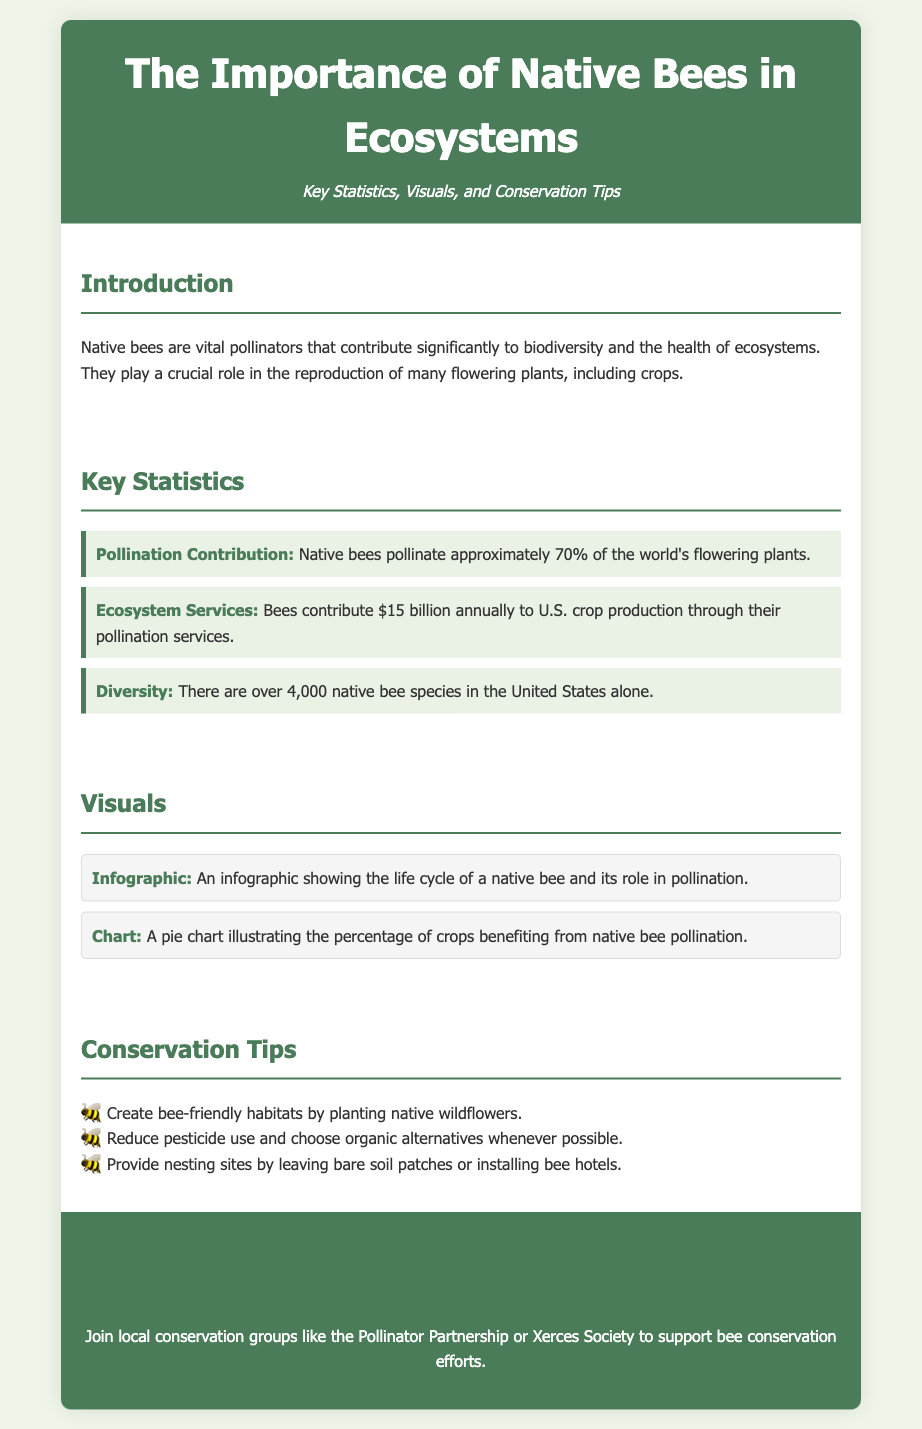What percentage of flowering plants are pollinated by native bees? The document states that native bees pollinate approximately 70% of the world's flowering plants.
Answer: 70% How much do bees contribute annually to U.S. crop production? The document mentions that bees contribute $15 billion annually to U.S. crop production.
Answer: $15 billion How many native bee species are there in the United States? It is mentioned in the document that there are over 4,000 native bee species in the United States.
Answer: Over 4,000 What type of visual represents the life cycle of a native bee? The document describes an infographic that shows the life cycle of a native bee and its role in pollination.
Answer: Infographic What is one of the conservation tips provided in the document? The document lists several tips, one of which is to create bee-friendly habitats by planting native wildflowers.
Answer: Planting native wildflowers Why is it important to reduce pesticide use according to the document? The document suggests reducing pesticide use to support bee conservation and is implied to be beneficial for native bees.
Answer: Support bee conservation Which organization can people join to support bee conservation efforts? The document mentions joining local conservation groups like the Pollinator Partnership or Xerces Society.
Answer: Pollinator Partnership What does the pie chart represent in the visuals section? The document states that the pie chart illustrates the percentage of crops benefiting from native bee pollination.
Answer: Percentage of crops benefiting 